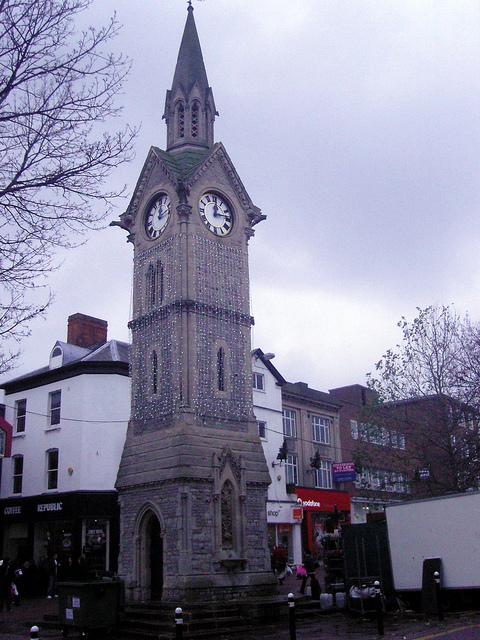What color is the brickwork on this building?
Write a very short answer. Gray. What time is it on the clock?
Keep it brief. 3:00. What time is displayed on the bell tower?
Give a very brief answer. 3:00. What style architecture is exemplified in the clock tower?
Short answer required. Gothic. What time does the clock say?
Keep it brief. 3:00. What season is this?
Be succinct. Fall. Is there a church in this photo?
Concise answer only. Yes. Is this a church?
Quick response, please. Yes. What time is it?
Answer briefly. 3:00. What regional architecture is represented here?
Answer briefly. Gothic. What color is the tower?
Concise answer only. Gray. 